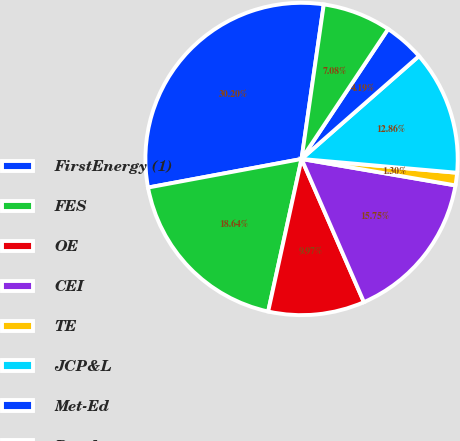<chart> <loc_0><loc_0><loc_500><loc_500><pie_chart><fcel>FirstEnergy (1)<fcel>FES<fcel>OE<fcel>CEI<fcel>TE<fcel>JCP&L<fcel>Met-Ed<fcel>Penelec<nl><fcel>30.2%<fcel>18.64%<fcel>9.97%<fcel>15.75%<fcel>1.3%<fcel>12.86%<fcel>4.19%<fcel>7.08%<nl></chart> 